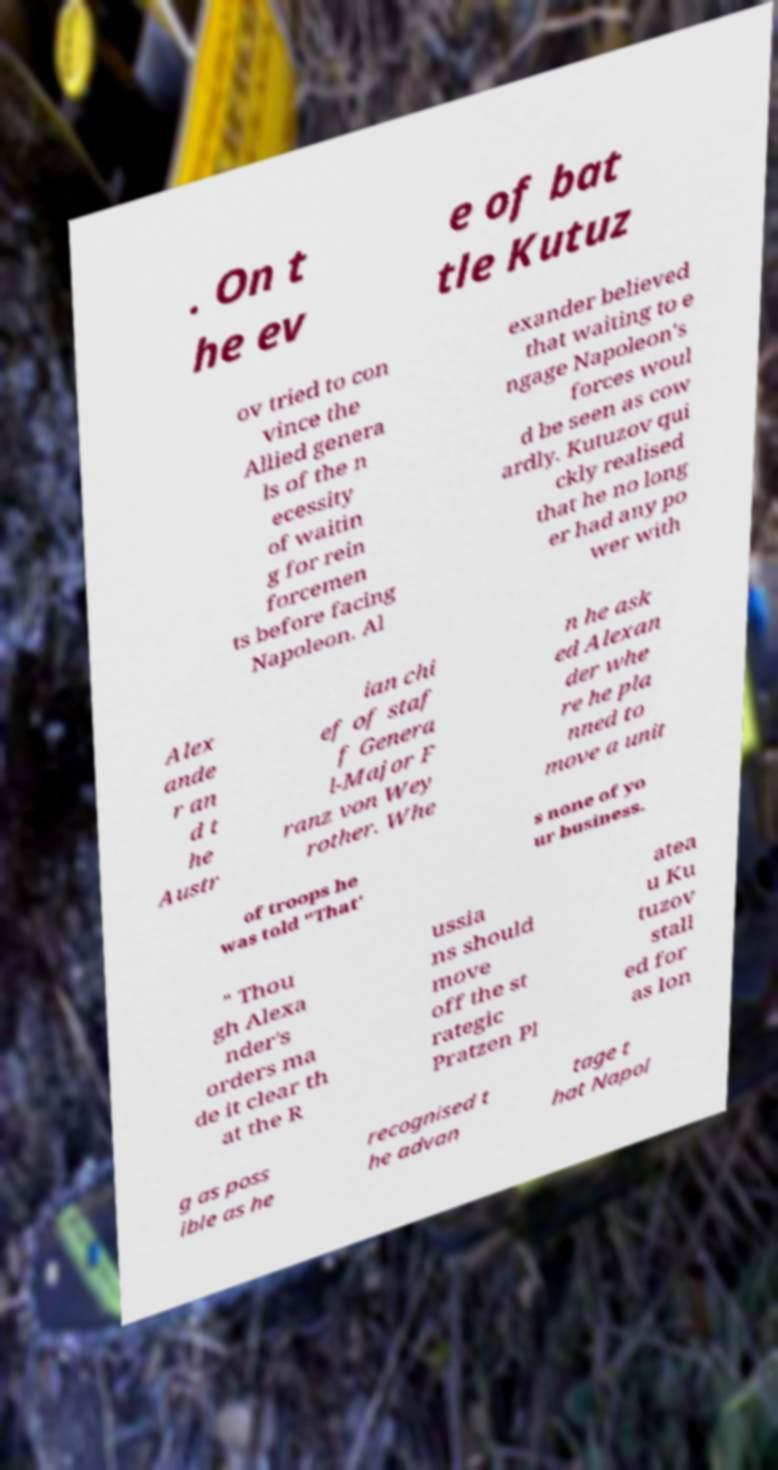Could you assist in decoding the text presented in this image and type it out clearly? . On t he ev e of bat tle Kutuz ov tried to con vince the Allied genera ls of the n ecessity of waitin g for rein forcemen ts before facing Napoleon. Al exander believed that waiting to e ngage Napoleon's forces woul d be seen as cow ardly. Kutuzov qui ckly realised that he no long er had any po wer with Alex ande r an d t he Austr ian chi ef of staf f Genera l-Major F ranz von Wey rother. Whe n he ask ed Alexan der whe re he pla nned to move a unit of troops he was told "That' s none of yo ur business. " Thou gh Alexa nder's orders ma de it clear th at the R ussia ns should move off the st rategic Pratzen Pl atea u Ku tuzov stall ed for as lon g as poss ible as he recognised t he advan tage t hat Napol 